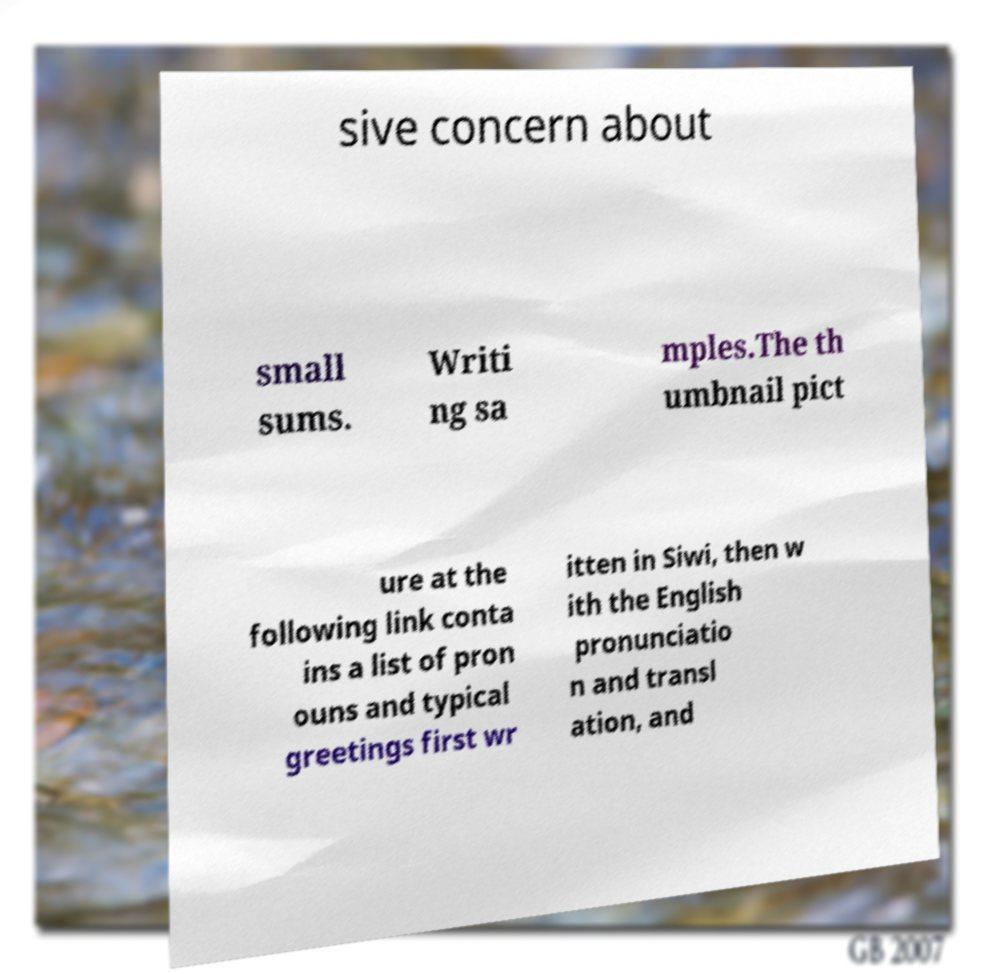What messages or text are displayed in this image? I need them in a readable, typed format. sive concern about small sums. Writi ng sa mples.The th umbnail pict ure at the following link conta ins a list of pron ouns and typical greetings first wr itten in Siwi, then w ith the English pronunciatio n and transl ation, and 